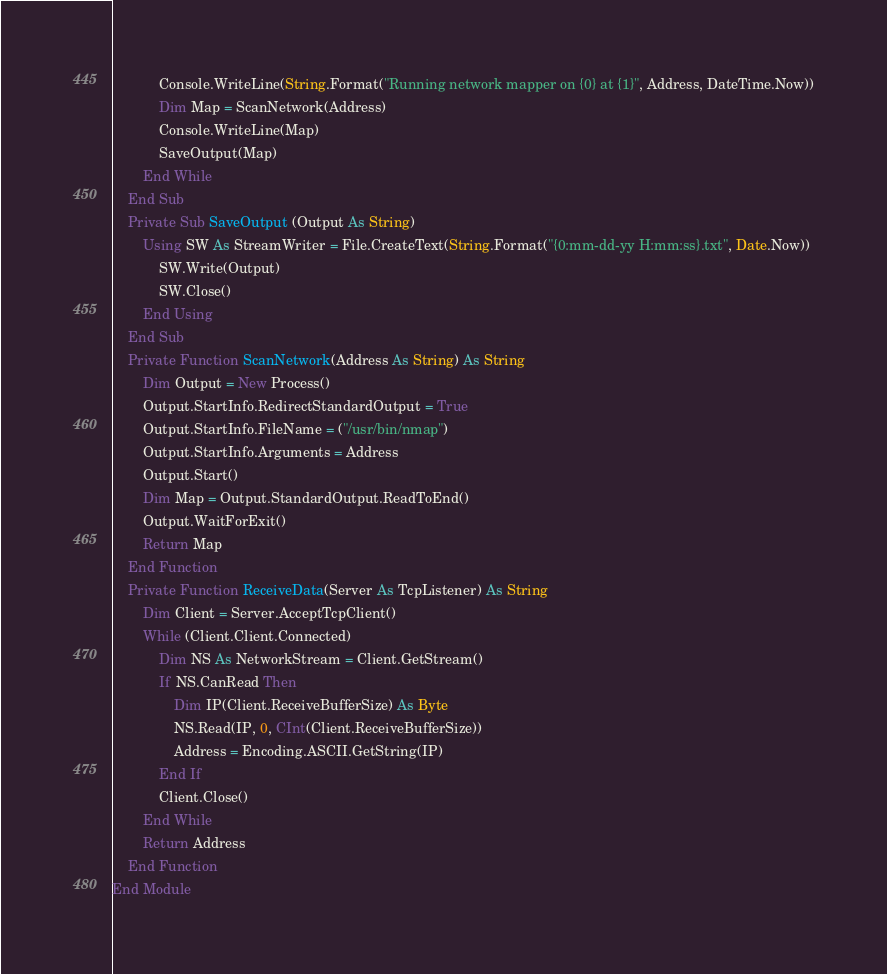<code> <loc_0><loc_0><loc_500><loc_500><_VisualBasic_>            Console.WriteLine(String.Format("Running network mapper on {0} at {1}", Address, DateTime.Now))
            Dim Map = ScanNetwork(Address)
            Console.WriteLine(Map)
            SaveOutput(Map)
        End While
    End Sub
    Private Sub SaveOutput (Output As String)
        Using SW As StreamWriter = File.CreateText(String.Format("{0:mm-dd-yy H:mm:ss}.txt", Date.Now))
            SW.Write(Output)
            SW.Close()
        End Using
    End Sub
    Private Function ScanNetwork(Address As String) As String
        Dim Output = New Process()
        Output.StartInfo.RedirectStandardOutput = True
        Output.StartInfo.FileName = ("/usr/bin/nmap")
        Output.StartInfo.Arguments = Address
        Output.Start()
        Dim Map = Output.StandardOutput.ReadToEnd()
        Output.WaitForExit()
        Return Map
    End Function
    Private Function ReceiveData(Server As TcpListener) As String
        Dim Client = Server.AcceptTcpClient()
        While (Client.Client.Connected)
            Dim NS As NetworkStream = Client.GetStream()
            If NS.CanRead Then
                Dim IP(Client.ReceiveBufferSize) As Byte
                NS.Read(IP, 0, CInt(Client.ReceiveBufferSize))
                Address = Encoding.ASCII.GetString(IP)
            End If
            Client.Close()
        End While
        Return Address
    End Function
End Module
</code> 